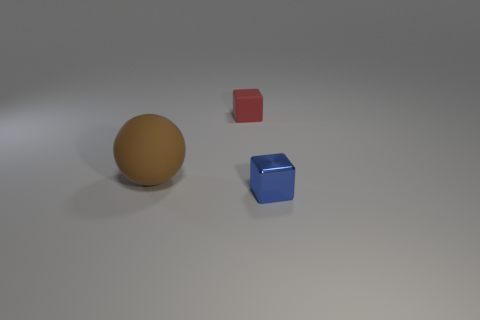Subtract all gray spheres. Subtract all yellow blocks. How many spheres are left? 1 Add 2 large spheres. How many objects exist? 5 Subtract all balls. How many objects are left? 2 Subtract all big purple objects. Subtract all rubber blocks. How many objects are left? 2 Add 1 small blue metallic objects. How many small blue metallic objects are left? 2 Add 2 purple shiny cylinders. How many purple shiny cylinders exist? 2 Subtract 0 yellow cylinders. How many objects are left? 3 